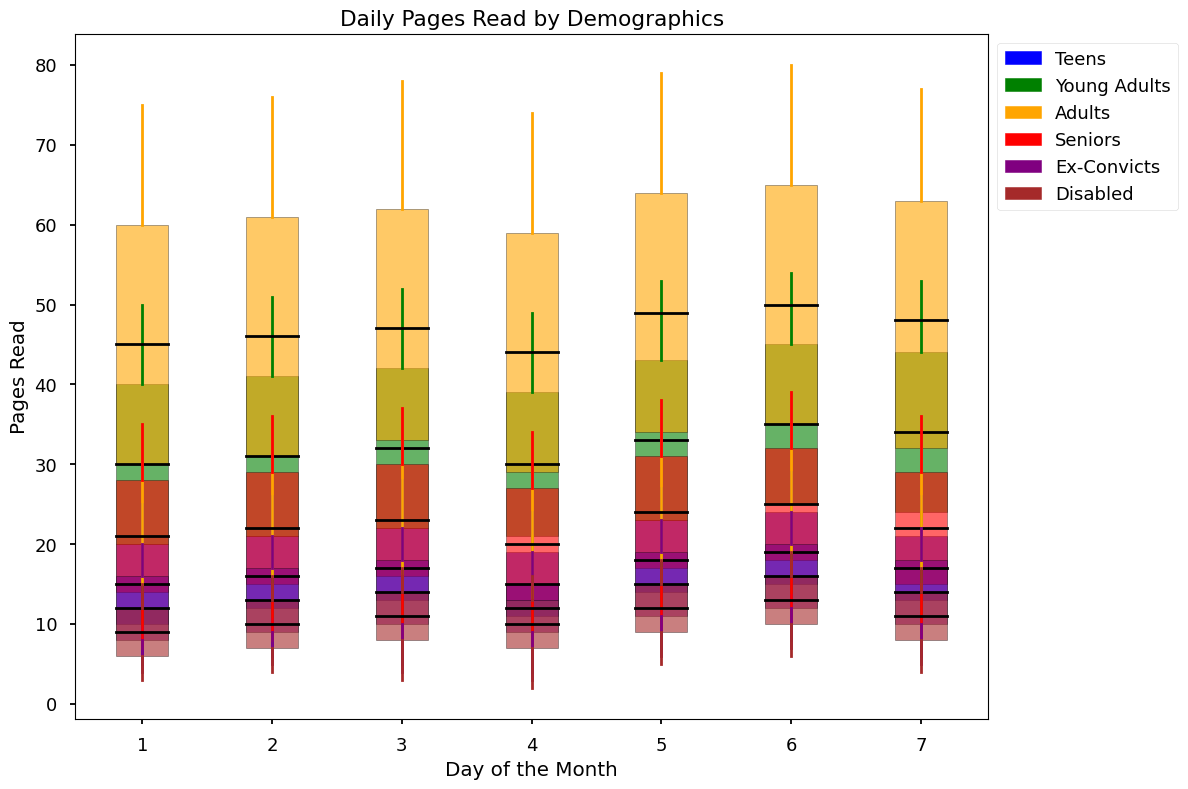What demographic group has the highest maximum value on Day 4? On Day 4, look at the topmost points of the candlestick charts for each demographic. The highest value is found in the group with the highest maximum line.
Answer: Adults Which demographic has the widest interquartile range (IQR) on Day 1? The IQR is represented by the height of the rectangles in the candlestick chart. Look for the tallest rectangle on Day 1.
Answer: Adults What is the difference between the maximum pages read by Teens and Ex-Convicts on Day 5? Find the topmost points for Teens and Ex-Convicts on Day 5 and subtract the Ex-Convicts' value from the Teens'. Teens have 27 pages, and Ex-Convicts have 23 pages, so the difference is 27 - 23.
Answer: 4 Which two demographics have the closest median on Day 6? On Day 6, identify the lines within the rectangles that represent the median for each demographic. The two closest lines in height will indicate the closest medians.
Answer: Ex-Convicts and Disabled On which day do Seniors have their lowest minimum value? The minimum value is represented by the bottommost points of the candlestick for Seniors. Look for the lowest bottom point across all days for Seniors.
Answer: Day 4 What is the sum of the median values for Young Adults from Day 1 to Day 3? Identify the median values (central line in the rectangles) for Young Adults on Days 1, 2, and 3, then sum these values: 30 + 31 + 32.
Answer: 93 How does the maximum value for Disabled on Day 7 compare to the maximum value for Ex-Convicts on the same day? Compare the topmost points of the candlestick for Disabled and Ex-Convicts on Day 7.
Answer: Equal Which day shows the highest variation in pages read among Young Adults? Variation can be observed by the total height (range) of the candlesticks. For Young Adults, find the day with the tallest candlestick, indicating the highest variation.
Answer: Day 6 Is there a day when the median value of Teens is higher than the median value of Seniors? If so, which day? Compare the median lines (middle of the rectangle) for Teens and Seniors across all days. Look for any days where the Teens' median exceeds that of Seniors.
Answer: Yes, Day 1 